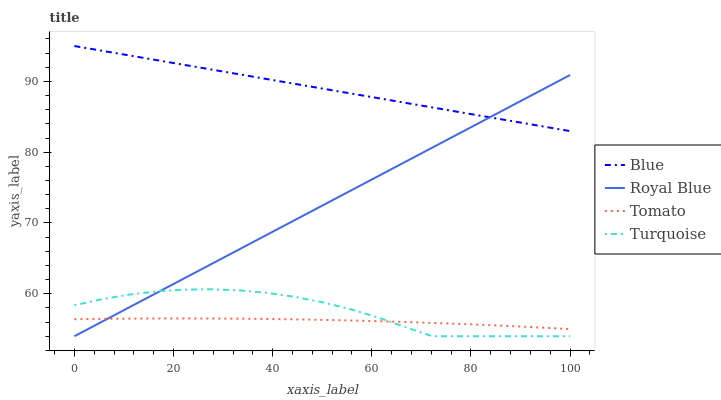Does Tomato have the minimum area under the curve?
Answer yes or no. Yes. Does Blue have the maximum area under the curve?
Answer yes or no. Yes. Does Royal Blue have the minimum area under the curve?
Answer yes or no. No. Does Royal Blue have the maximum area under the curve?
Answer yes or no. No. Is Blue the smoothest?
Answer yes or no. Yes. Is Turquoise the roughest?
Answer yes or no. Yes. Is Royal Blue the smoothest?
Answer yes or no. No. Is Royal Blue the roughest?
Answer yes or no. No. Does Tomato have the lowest value?
Answer yes or no. No. Does Royal Blue have the highest value?
Answer yes or no. No. Is Turquoise less than Blue?
Answer yes or no. Yes. Is Blue greater than Turquoise?
Answer yes or no. Yes. Does Turquoise intersect Blue?
Answer yes or no. No. 